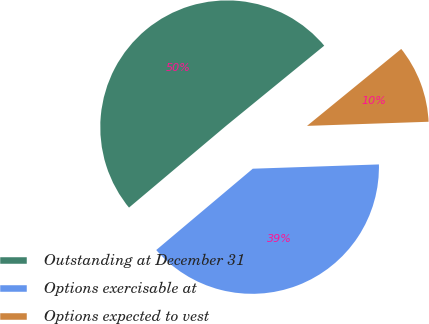<chart> <loc_0><loc_0><loc_500><loc_500><pie_chart><fcel>Outstanding at December 31<fcel>Options exercisable at<fcel>Options expected to vest<nl><fcel>50.24%<fcel>39.4%<fcel>10.36%<nl></chart> 